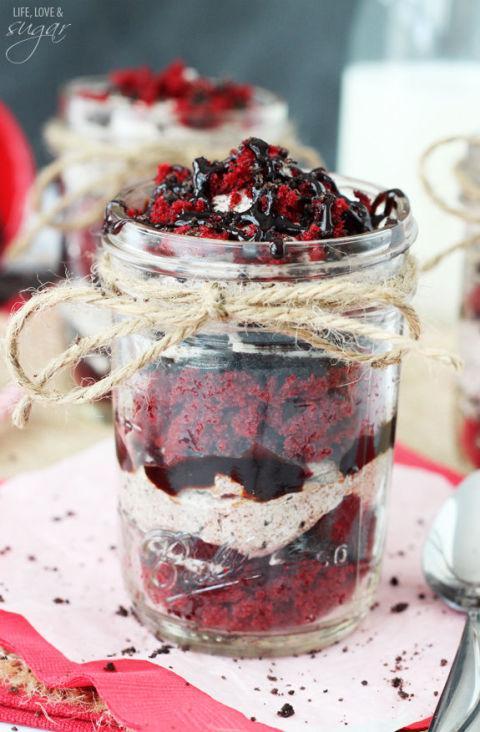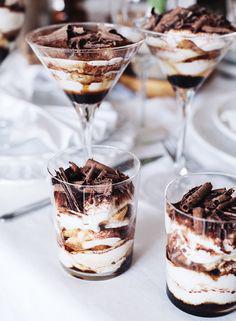The first image is the image on the left, the second image is the image on the right. Considering the images on both sides, is "there are roses on the table next to desserts with chocolate drizzled on top" valid? Answer yes or no. No. 